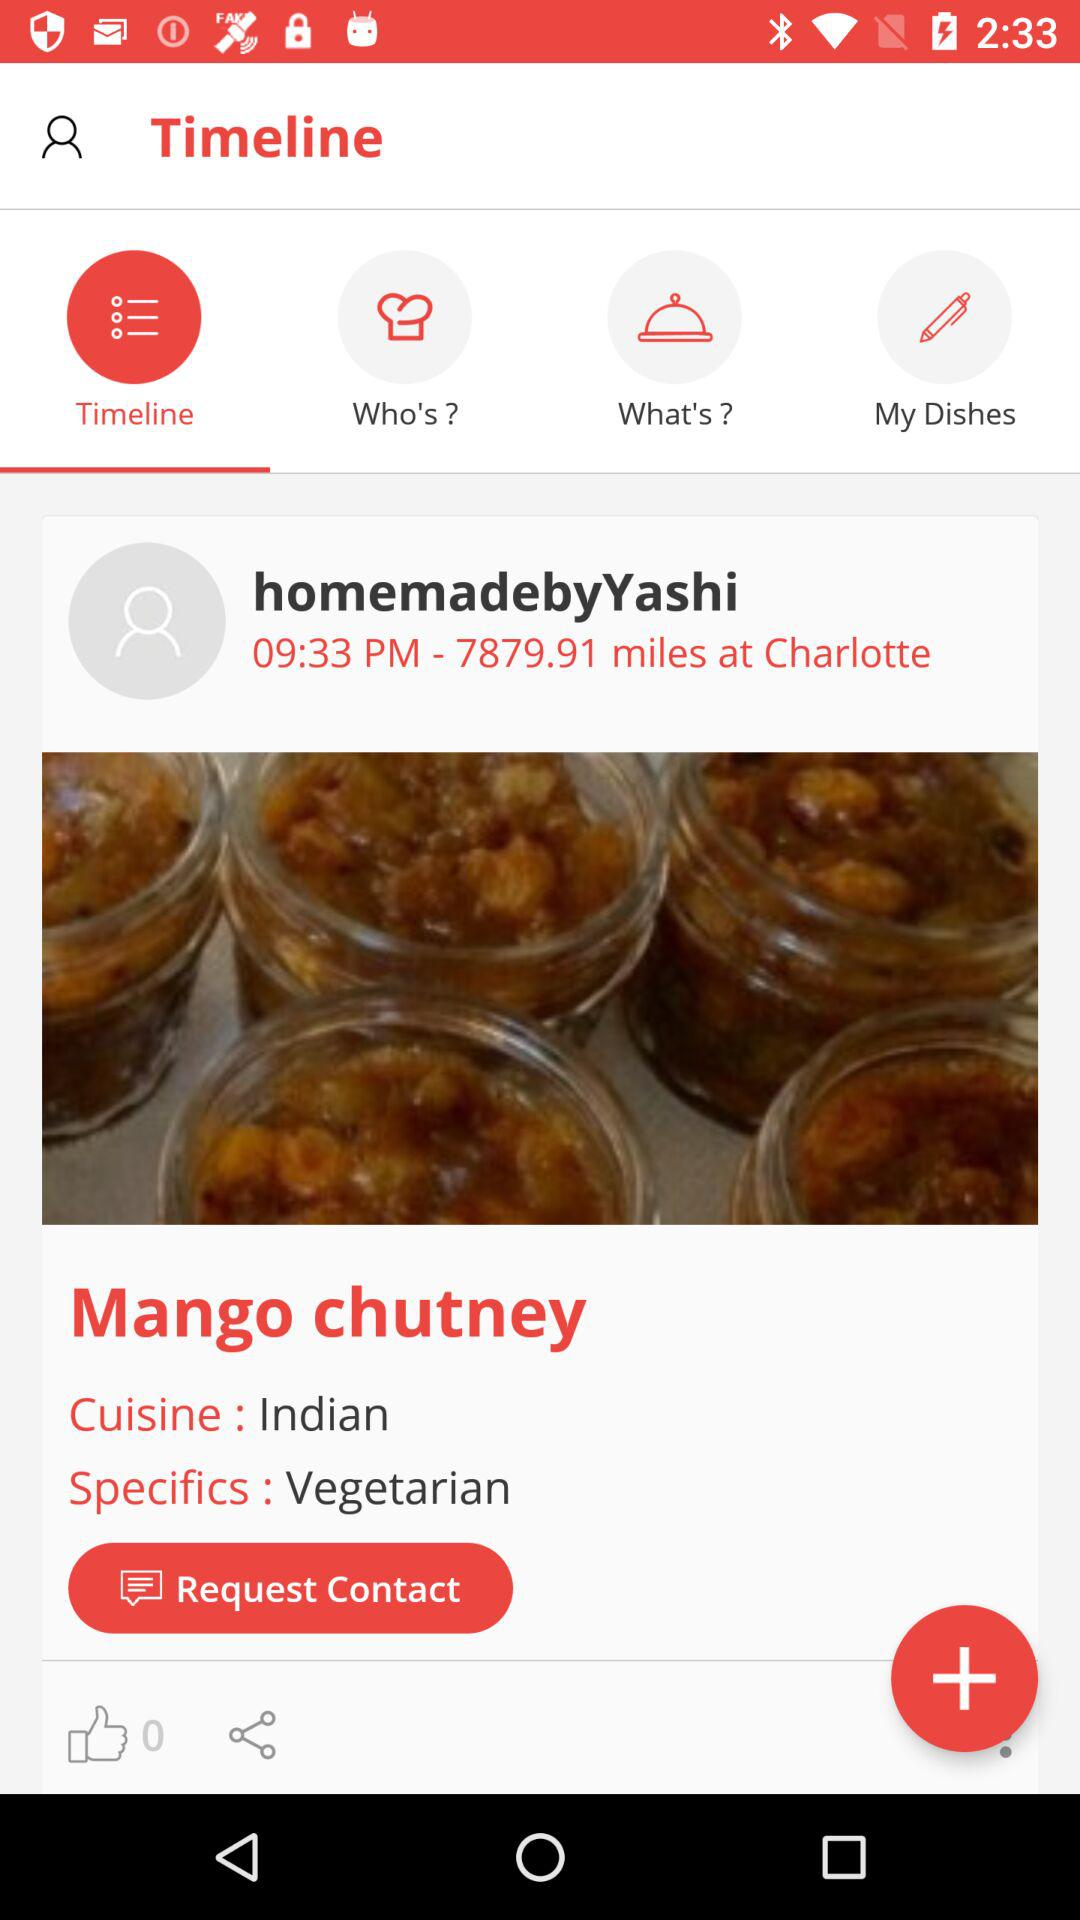What are the specifics of "Mango chutney"? The specifics are "Vegetarian". 